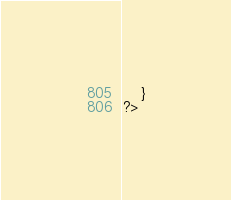Convert code to text. <code><loc_0><loc_0><loc_500><loc_500><_PHP_>    }
?>
</code> 